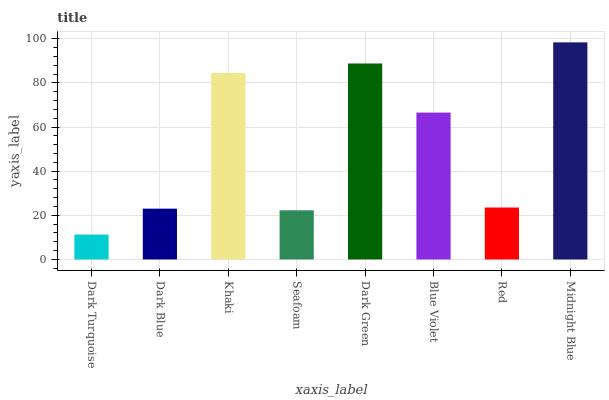Is Dark Turquoise the minimum?
Answer yes or no. Yes. Is Midnight Blue the maximum?
Answer yes or no. Yes. Is Dark Blue the minimum?
Answer yes or no. No. Is Dark Blue the maximum?
Answer yes or no. No. Is Dark Blue greater than Dark Turquoise?
Answer yes or no. Yes. Is Dark Turquoise less than Dark Blue?
Answer yes or no. Yes. Is Dark Turquoise greater than Dark Blue?
Answer yes or no. No. Is Dark Blue less than Dark Turquoise?
Answer yes or no. No. Is Blue Violet the high median?
Answer yes or no. Yes. Is Red the low median?
Answer yes or no. Yes. Is Khaki the high median?
Answer yes or no. No. Is Dark Turquoise the low median?
Answer yes or no. No. 